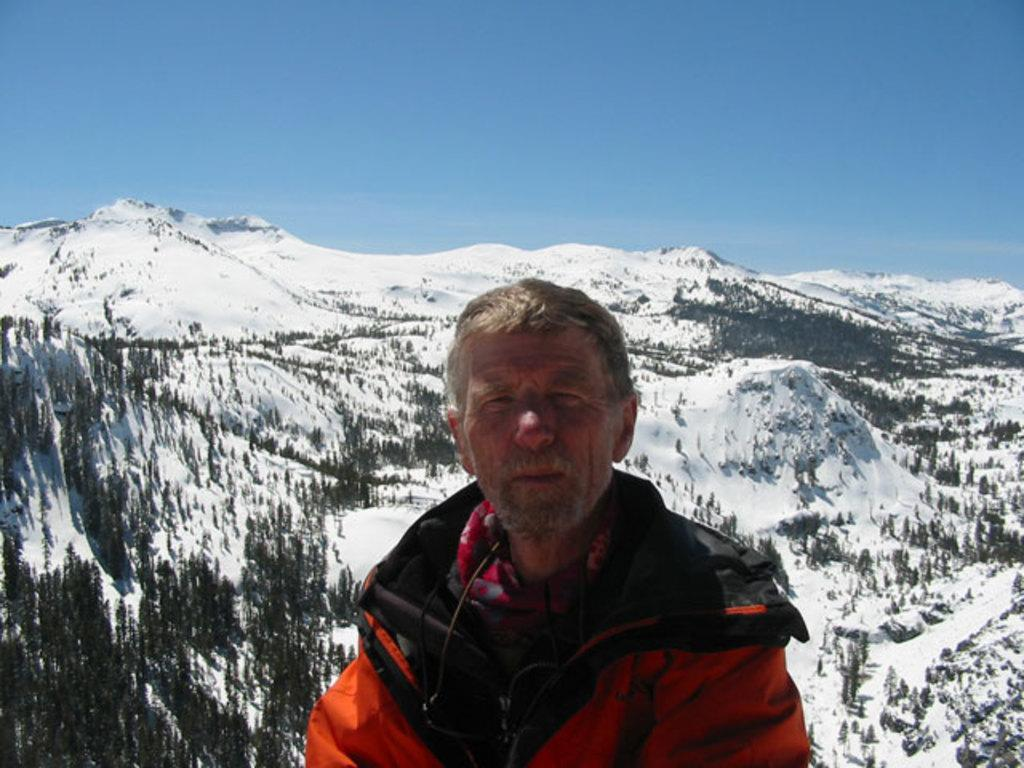Who is the main subject in the picture? There is an old man in the picture. What is the old man wearing? The old man is wearing a red jacket. What is the old man doing in the picture? The old man is standing and looking into the camera. What can be seen in the background of the picture? There is a huge mountain in the background of the picture, and there are trees on the mountain. What type of fold can be seen in the old man's jacket in the image? There is no fold visible in the old man's jacket in the image. Is the old man holding a rifle in the image? There is no rifle present in the image. 